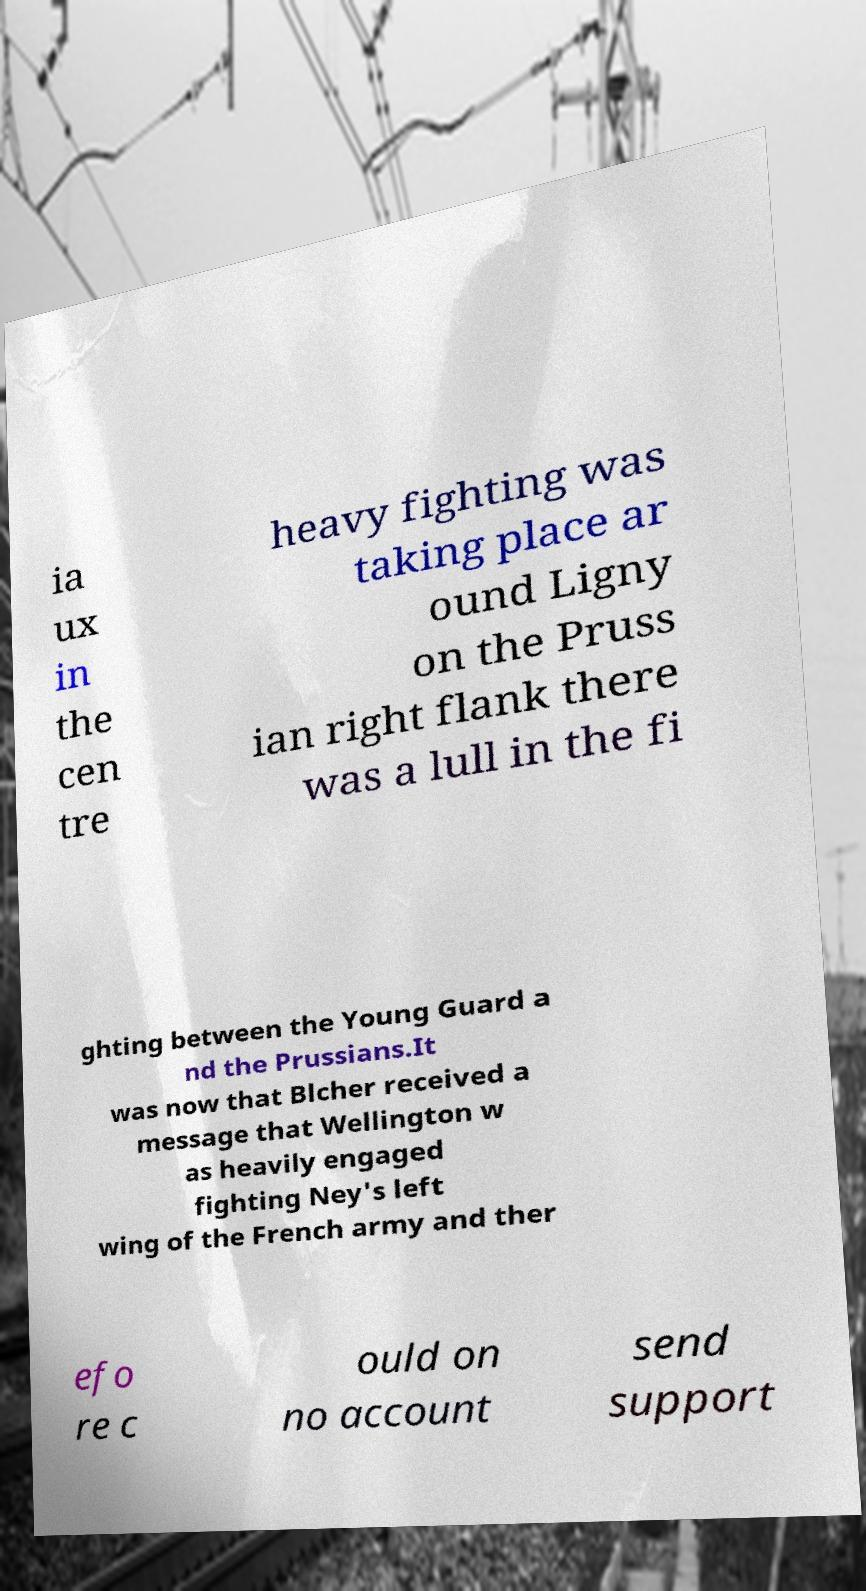Can you read and provide the text displayed in the image?This photo seems to have some interesting text. Can you extract and type it out for me? ia ux in the cen tre heavy fighting was taking place ar ound Ligny on the Pruss ian right flank there was a lull in the fi ghting between the Young Guard a nd the Prussians.It was now that Blcher received a message that Wellington w as heavily engaged fighting Ney's left wing of the French army and ther efo re c ould on no account send support 